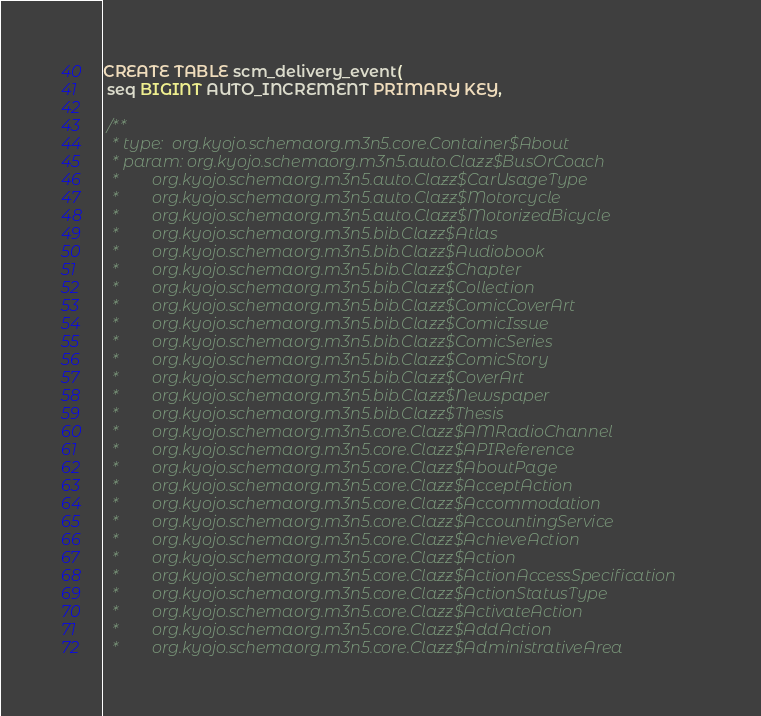Convert code to text. <code><loc_0><loc_0><loc_500><loc_500><_SQL_>CREATE TABLE scm_delivery_event(
 seq BIGINT AUTO_INCREMENT PRIMARY KEY,

 /**
  * type:  org.kyojo.schemaorg.m3n5.core.Container$About
  * param: org.kyojo.schemaorg.m3n5.auto.Clazz$BusOrCoach
  *        org.kyojo.schemaorg.m3n5.auto.Clazz$CarUsageType
  *        org.kyojo.schemaorg.m3n5.auto.Clazz$Motorcycle
  *        org.kyojo.schemaorg.m3n5.auto.Clazz$MotorizedBicycle
  *        org.kyojo.schemaorg.m3n5.bib.Clazz$Atlas
  *        org.kyojo.schemaorg.m3n5.bib.Clazz$Audiobook
  *        org.kyojo.schemaorg.m3n5.bib.Clazz$Chapter
  *        org.kyojo.schemaorg.m3n5.bib.Clazz$Collection
  *        org.kyojo.schemaorg.m3n5.bib.Clazz$ComicCoverArt
  *        org.kyojo.schemaorg.m3n5.bib.Clazz$ComicIssue
  *        org.kyojo.schemaorg.m3n5.bib.Clazz$ComicSeries
  *        org.kyojo.schemaorg.m3n5.bib.Clazz$ComicStory
  *        org.kyojo.schemaorg.m3n5.bib.Clazz$CoverArt
  *        org.kyojo.schemaorg.m3n5.bib.Clazz$Newspaper
  *        org.kyojo.schemaorg.m3n5.bib.Clazz$Thesis
  *        org.kyojo.schemaorg.m3n5.core.Clazz$AMRadioChannel
  *        org.kyojo.schemaorg.m3n5.core.Clazz$APIReference
  *        org.kyojo.schemaorg.m3n5.core.Clazz$AboutPage
  *        org.kyojo.schemaorg.m3n5.core.Clazz$AcceptAction
  *        org.kyojo.schemaorg.m3n5.core.Clazz$Accommodation
  *        org.kyojo.schemaorg.m3n5.core.Clazz$AccountingService
  *        org.kyojo.schemaorg.m3n5.core.Clazz$AchieveAction
  *        org.kyojo.schemaorg.m3n5.core.Clazz$Action
  *        org.kyojo.schemaorg.m3n5.core.Clazz$ActionAccessSpecification
  *        org.kyojo.schemaorg.m3n5.core.Clazz$ActionStatusType
  *        org.kyojo.schemaorg.m3n5.core.Clazz$ActivateAction
  *        org.kyojo.schemaorg.m3n5.core.Clazz$AddAction
  *        org.kyojo.schemaorg.m3n5.core.Clazz$AdministrativeArea</code> 